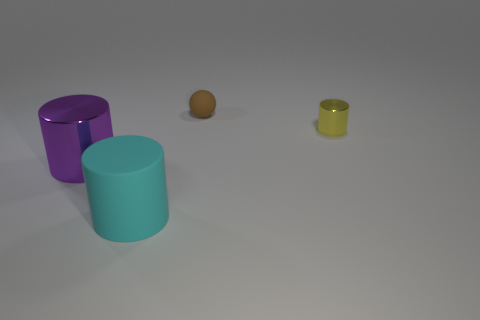Are there any reflective surfaces visible in this image, and if so, which objects are they? Yes, the surfaces of the cylinders appear to be slightly reflective. The yellow and purple cylinders, as well as the round ball, exhibit reflections and highlights indicating a shiny surface. 